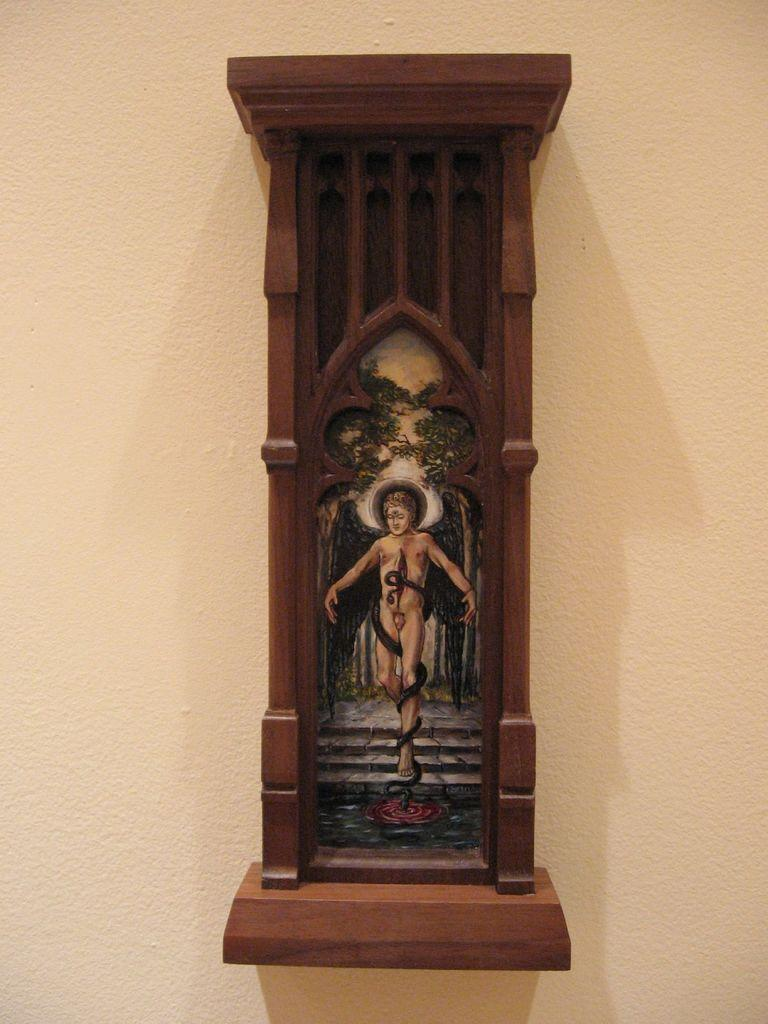What is attached to the wall in the image? There is a board attached to the wall in the image. What is depicted on the board? There is a painting of a person on the board. Is there any smoke coming from the person's hair in the painting? There is no smoke present in the image, and the painting does not depict a person with hair. 